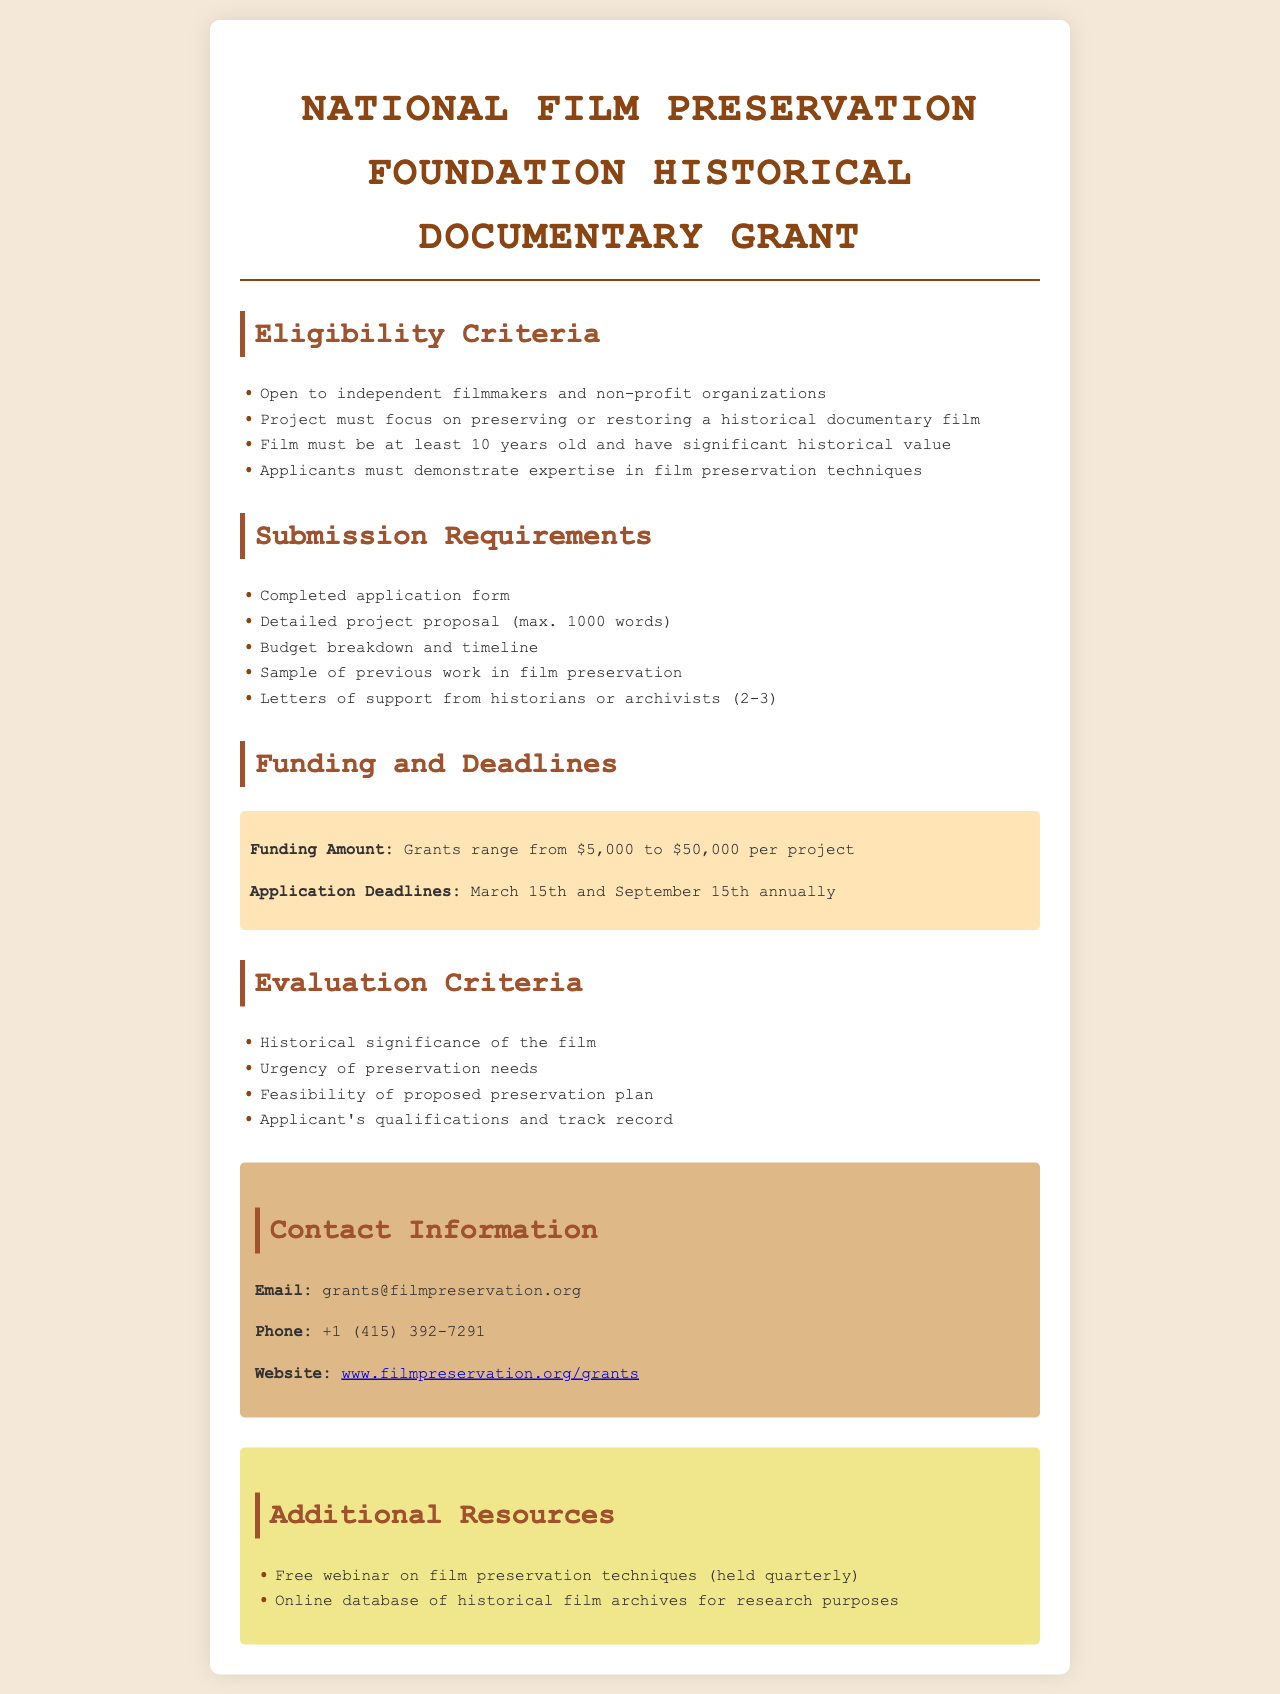What is the funding range for grants? The funding range is specified in the document as the amount provided for grants per project, which is from $5,000 to $50,000.
Answer: $5,000 to $50,000 Who can apply for the grant? The document mentions that eligibility is open to specific groups, which are independent filmmakers and non-profit organizations.
Answer: Independent filmmakers and non-profit organizations What is the maximum word count for the project proposal? The document sets a limit on the length of the project proposal, which is detailed as a maximum of 1,000 words.
Answer: 1000 words When are the application deadlines? The specific dates for submission each year are outlined in the funding and deadlines section, referring to March 15th and September 15th.
Answer: March 15th and September 15th What must applicants demonstrate in their application? The document states that applicants are required to show expertise in a particular area, which is film preservation techniques.
Answer: Expertise in film preservation techniques How many letters of support are required? The requirements detail that a certain number of letters from professionals is necessary, which is noted as 2 to 3 letters.
Answer: 2-3 letters What is the main focus of the projects eligible for funding? The document describes the projects that should be centered around preserving or restoring a certain type of film, which are historical documentary films.
Answer: Preserving or restoring a historical documentary film What is one of the evaluation criteria? The document lists several aspects that are taken into account during evaluation; one such criteria is the historical significance of the film.
Answer: Historical significance of the film 